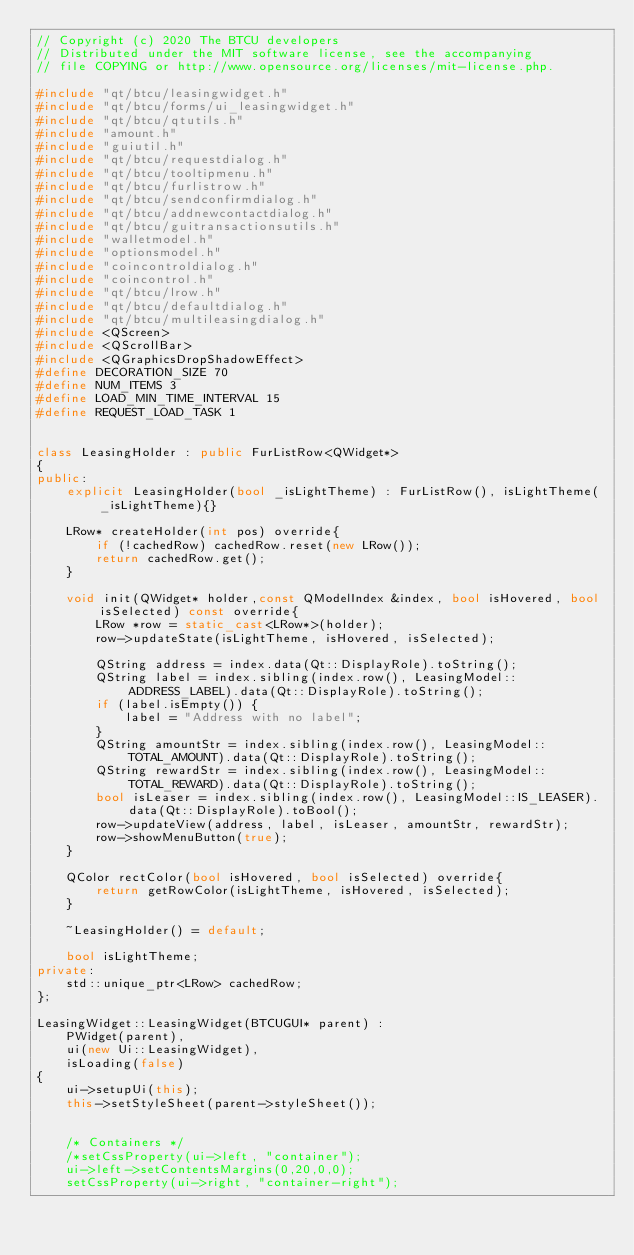Convert code to text. <code><loc_0><loc_0><loc_500><loc_500><_C++_>// Copyright (c) 2020 The BTCU developers
// Distributed under the MIT software license, see the accompanying
// file COPYING or http://www.opensource.org/licenses/mit-license.php.

#include "qt/btcu/leasingwidget.h"
#include "qt/btcu/forms/ui_leasingwidget.h"
#include "qt/btcu/qtutils.h"
#include "amount.h"
#include "guiutil.h"
#include "qt/btcu/requestdialog.h"
#include "qt/btcu/tooltipmenu.h"
#include "qt/btcu/furlistrow.h"
#include "qt/btcu/sendconfirmdialog.h"
#include "qt/btcu/addnewcontactdialog.h"
#include "qt/btcu/guitransactionsutils.h"
#include "walletmodel.h"
#include "optionsmodel.h"
#include "coincontroldialog.h"
#include "coincontrol.h"
#include "qt/btcu/lrow.h"
#include "qt/btcu/defaultdialog.h"
#include "qt/btcu/multileasingdialog.h"
#include <QScreen>
#include <QScrollBar>
#include <QGraphicsDropShadowEffect>
#define DECORATION_SIZE 70
#define NUM_ITEMS 3
#define LOAD_MIN_TIME_INTERVAL 15
#define REQUEST_LOAD_TASK 1


class LeasingHolder : public FurListRow<QWidget*>
{
public:
    explicit LeasingHolder(bool _isLightTheme) : FurListRow(), isLightTheme(_isLightTheme){}

    LRow* createHolder(int pos) override{
        if (!cachedRow) cachedRow.reset(new LRow());
        return cachedRow.get();
    }

    void init(QWidget* holder,const QModelIndex &index, bool isHovered, bool isSelected) const override{
        LRow *row = static_cast<LRow*>(holder);
        row->updateState(isLightTheme, isHovered, isSelected);

        QString address = index.data(Qt::DisplayRole).toString();
        QString label = index.sibling(index.row(), LeasingModel::ADDRESS_LABEL).data(Qt::DisplayRole).toString();
        if (label.isEmpty()) {
            label = "Address with no label";
        }
        QString amountStr = index.sibling(index.row(), LeasingModel::TOTAL_AMOUNT).data(Qt::DisplayRole).toString();
        QString rewardStr = index.sibling(index.row(), LeasingModel::TOTAL_REWARD).data(Qt::DisplayRole).toString();
        bool isLeaser = index.sibling(index.row(), LeasingModel::IS_LEASER).data(Qt::DisplayRole).toBool();
        row->updateView(address, label, isLeaser, amountStr, rewardStr);
        row->showMenuButton(true);
    }

    QColor rectColor(bool isHovered, bool isSelected) override{
        return getRowColor(isLightTheme, isHovered, isSelected);
    }

    ~LeasingHolder() = default;

    bool isLightTheme;
private:
    std::unique_ptr<LRow> cachedRow;
};

LeasingWidget::LeasingWidget(BTCUGUI* parent) :
    PWidget(parent),
    ui(new Ui::LeasingWidget),
    isLoading(false)
{
    ui->setupUi(this);
    this->setStyleSheet(parent->styleSheet());


    /* Containers */
    /*setCssProperty(ui->left, "container");
    ui->left->setContentsMargins(0,20,0,0);
    setCssProperty(ui->right, "container-right");</code> 